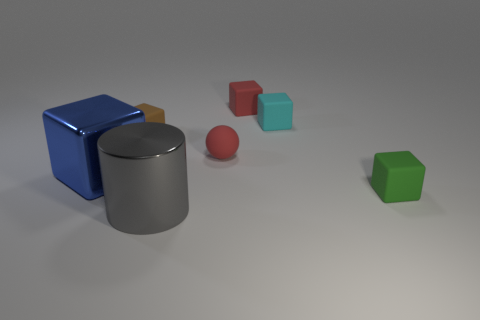Is the number of tiny red spheres on the left side of the blue thing the same as the number of tiny cubes that are in front of the small red block?
Provide a succinct answer. No. The shiny thing that is behind the green matte object is what color?
Your answer should be very brief. Blue. Is the number of shiny blocks right of the small brown matte thing the same as the number of large blue objects?
Give a very brief answer. No. What number of other objects are there of the same shape as the small green thing?
Give a very brief answer. 4. There is a green rubber object; how many small red balls are to the left of it?
Offer a very short reply. 1. There is a block that is both behind the sphere and left of the large gray cylinder; how big is it?
Provide a succinct answer. Small. Are any tiny matte things visible?
Give a very brief answer. Yes. How many other objects are the same size as the red rubber ball?
Provide a succinct answer. 4. Is the color of the tiny thing that is behind the small cyan object the same as the ball that is in front of the cyan rubber block?
Provide a short and direct response. Yes. The brown matte object that is the same shape as the cyan thing is what size?
Provide a succinct answer. Small. 